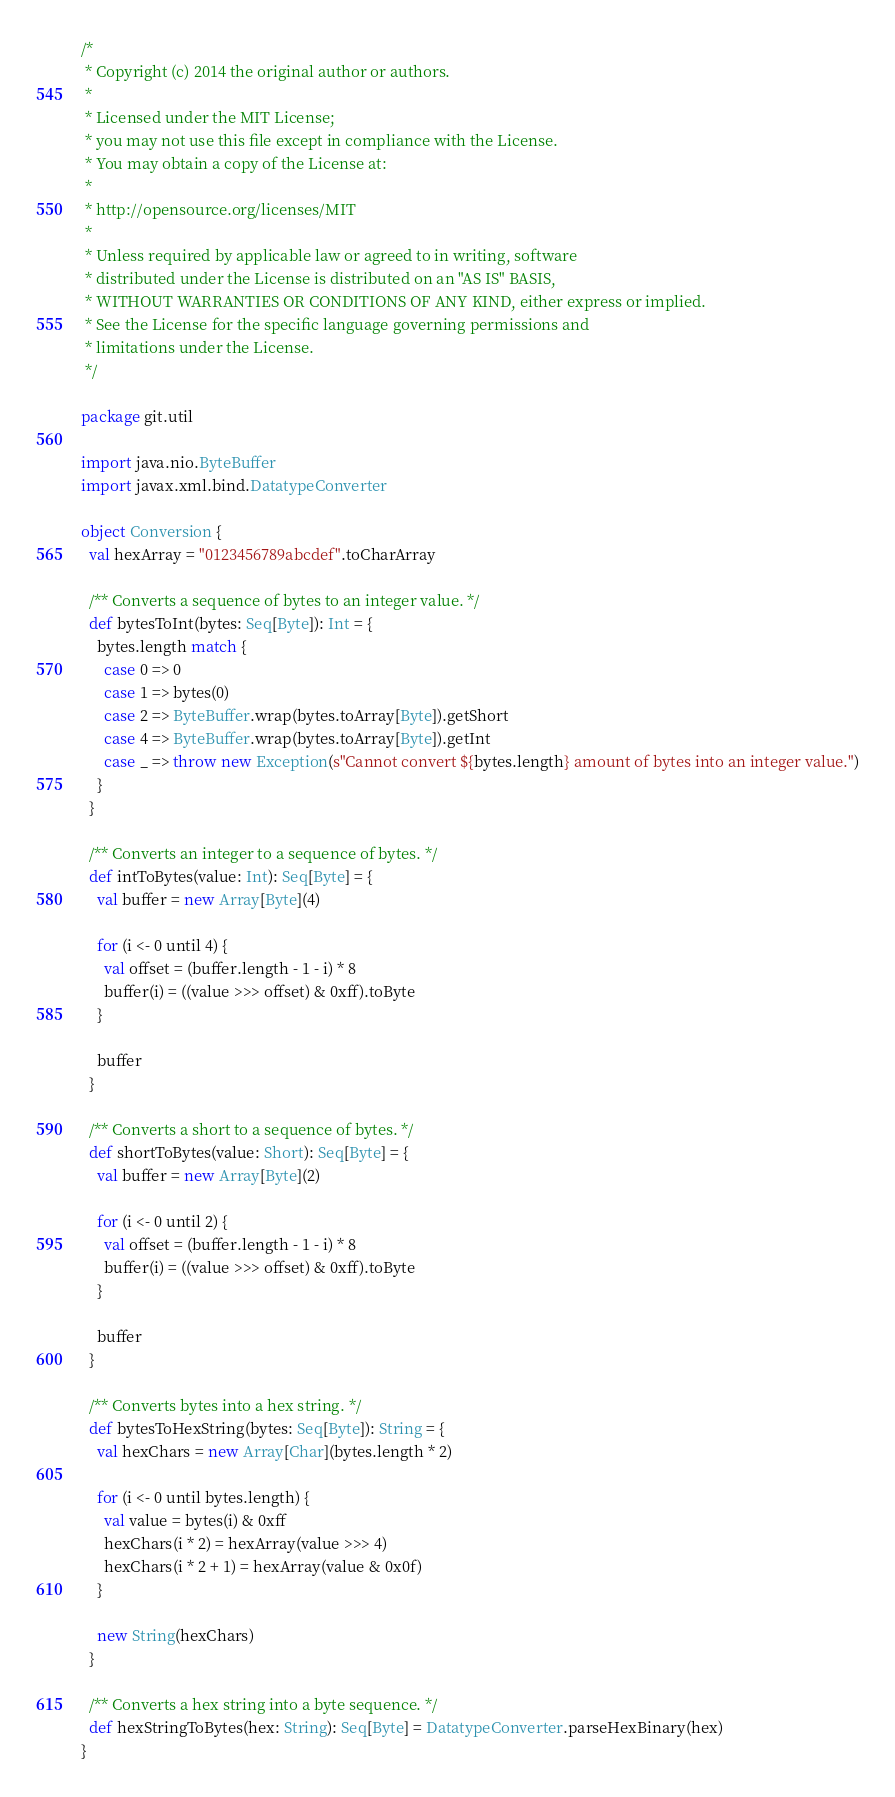Convert code to text. <code><loc_0><loc_0><loc_500><loc_500><_Scala_>/*
 * Copyright (c) 2014 the original author or authors.
 *
 * Licensed under the MIT License;
 * you may not use this file except in compliance with the License.
 * You may obtain a copy of the License at:
 *
 * http://opensource.org/licenses/MIT
 *
 * Unless required by applicable law or agreed to in writing, software
 * distributed under the License is distributed on an "AS IS" BASIS,
 * WITHOUT WARRANTIES OR CONDITIONS OF ANY KIND, either express or implied.
 * See the License for the specific language governing permissions and
 * limitations under the License.
 */

package git.util

import java.nio.ByteBuffer
import javax.xml.bind.DatatypeConverter

object Conversion {
  val hexArray = "0123456789abcdef".toCharArray

  /** Converts a sequence of bytes to an integer value. */
  def bytesToInt(bytes: Seq[Byte]): Int = {
    bytes.length match {
      case 0 => 0
      case 1 => bytes(0)
      case 2 => ByteBuffer.wrap(bytes.toArray[Byte]).getShort
      case 4 => ByteBuffer.wrap(bytes.toArray[Byte]).getInt
      case _ => throw new Exception(s"Cannot convert ${bytes.length} amount of bytes into an integer value.")
    }
  }

  /** Converts an integer to a sequence of bytes. */
  def intToBytes(value: Int): Seq[Byte] = {
    val buffer = new Array[Byte](4)

    for (i <- 0 until 4) {
      val offset = (buffer.length - 1 - i) * 8
      buffer(i) = ((value >>> offset) & 0xff).toByte
    }

    buffer
  }

  /** Converts a short to a sequence of bytes. */
  def shortToBytes(value: Short): Seq[Byte] = {
    val buffer = new Array[Byte](2)

    for (i <- 0 until 2) {
      val offset = (buffer.length - 1 - i) * 8
      buffer(i) = ((value >>> offset) & 0xff).toByte
    }

    buffer
  }

  /** Converts bytes into a hex string. */
  def bytesToHexString(bytes: Seq[Byte]): String = {
    val hexChars = new Array[Char](bytes.length * 2)

    for (i <- 0 until bytes.length) {
      val value = bytes(i) & 0xff
      hexChars(i * 2) = hexArray(value >>> 4)
      hexChars(i * 2 + 1) = hexArray(value & 0x0f)
    }

    new String(hexChars)
  }

  /** Converts a hex string into a byte sequence. */
  def hexStringToBytes(hex: String): Seq[Byte] = DatatypeConverter.parseHexBinary(hex)
}</code> 